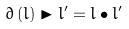Convert formula to latex. <formula><loc_0><loc_0><loc_500><loc_500>\partial \left ( l \right ) \blacktriangleright l ^ { \prime } = l \bullet l ^ { \prime }</formula> 